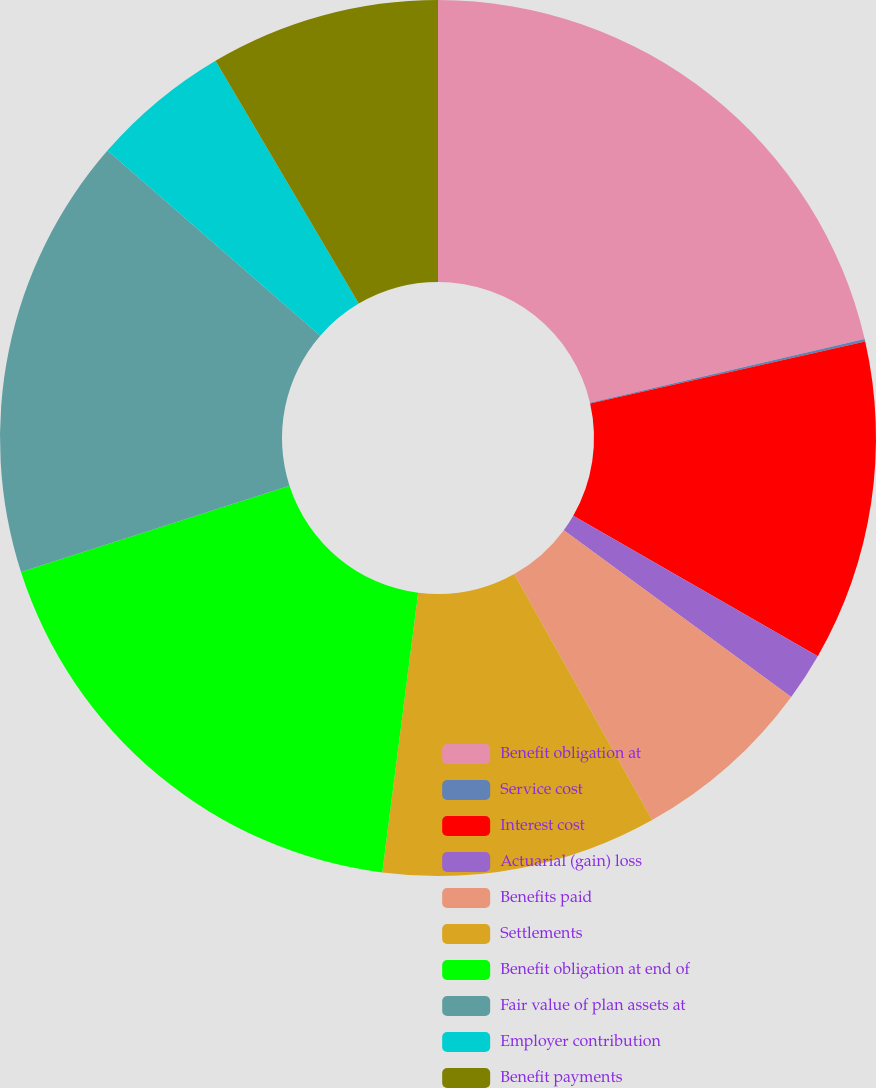Convert chart. <chart><loc_0><loc_0><loc_500><loc_500><pie_chart><fcel>Benefit obligation at<fcel>Service cost<fcel>Interest cost<fcel>Actuarial (gain) loss<fcel>Benefits paid<fcel>Settlements<fcel>Benefit obligation at end of<fcel>Fair value of plan assets at<fcel>Employer contribution<fcel>Benefit payments<nl><fcel>21.37%<fcel>0.09%<fcel>11.84%<fcel>1.77%<fcel>6.8%<fcel>10.16%<fcel>18.02%<fcel>16.34%<fcel>5.13%<fcel>8.48%<nl></chart> 